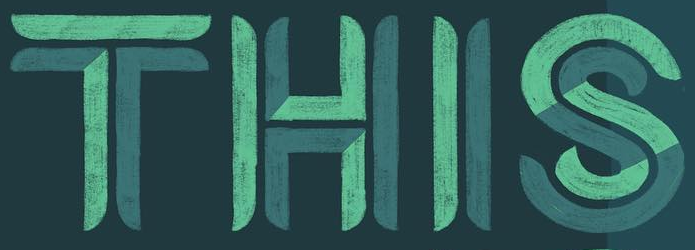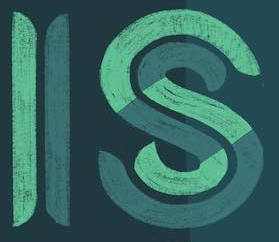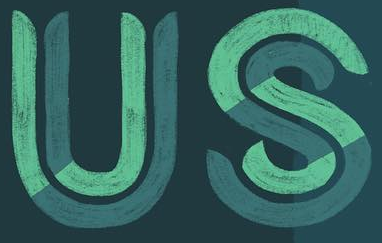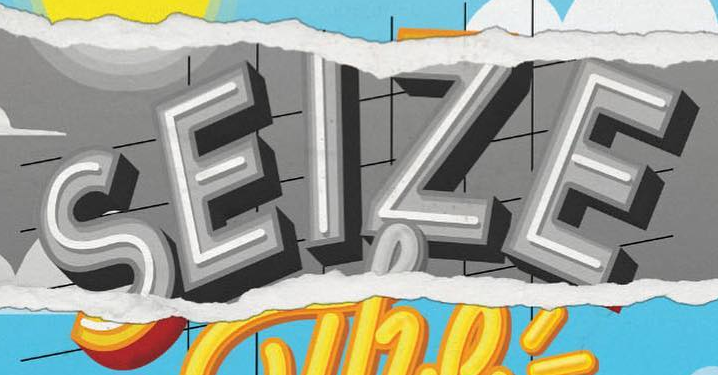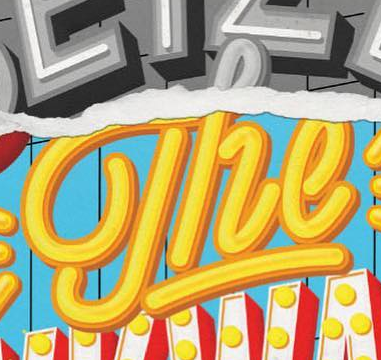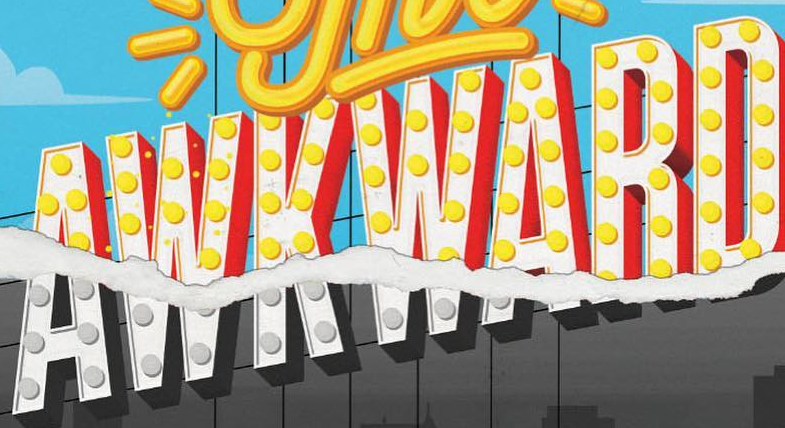What words can you see in these images in sequence, separated by a semicolon? THIS; IS; US; SEIZE; The; AWKWARD 